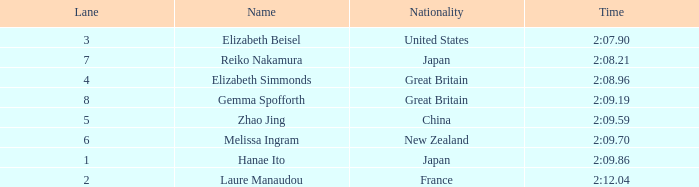What is laure manaudou's top position? 8.0. 